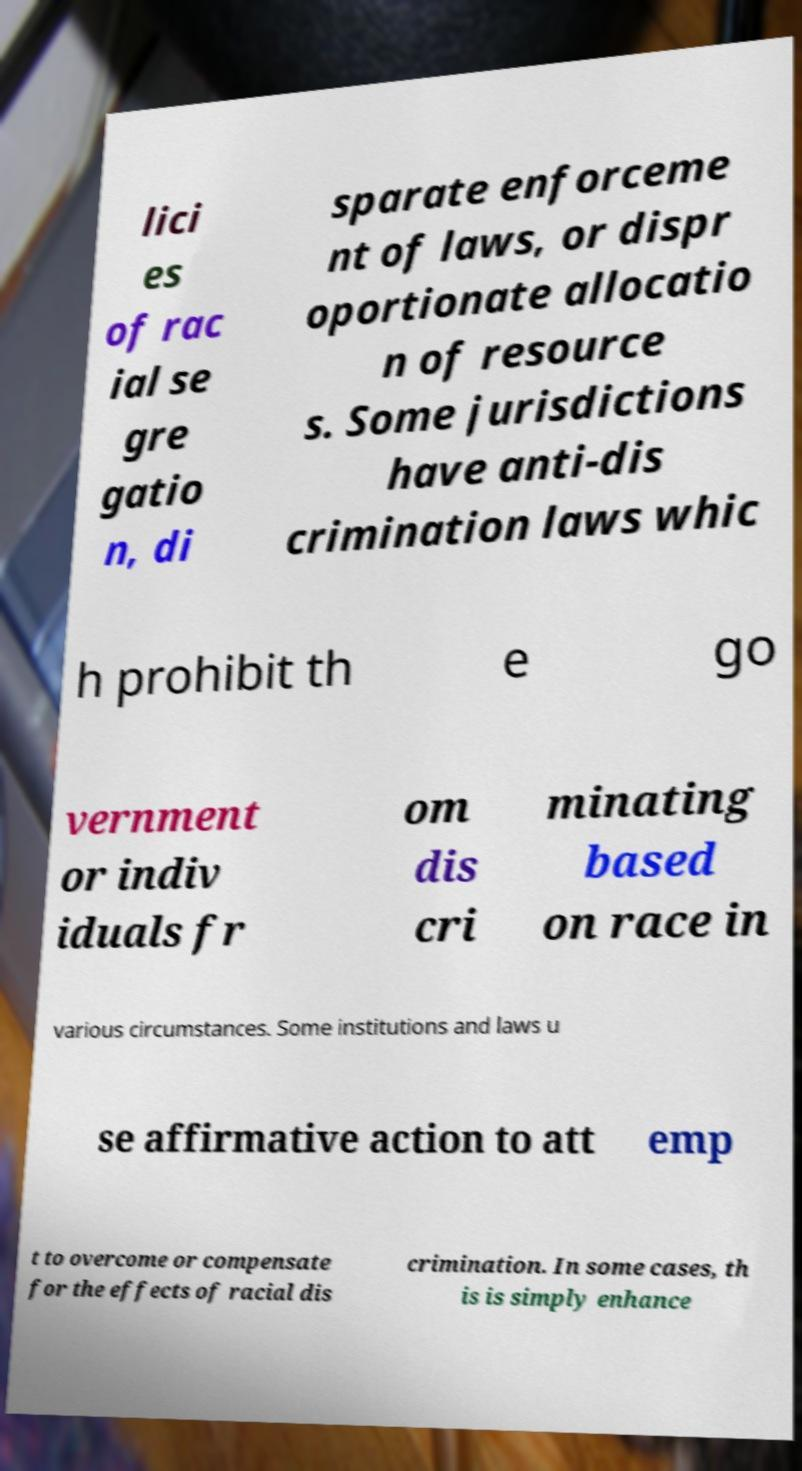Could you assist in decoding the text presented in this image and type it out clearly? lici es of rac ial se gre gatio n, di sparate enforceme nt of laws, or dispr oportionate allocatio n of resource s. Some jurisdictions have anti-dis crimination laws whic h prohibit th e go vernment or indiv iduals fr om dis cri minating based on race in various circumstances. Some institutions and laws u se affirmative action to att emp t to overcome or compensate for the effects of racial dis crimination. In some cases, th is is simply enhance 